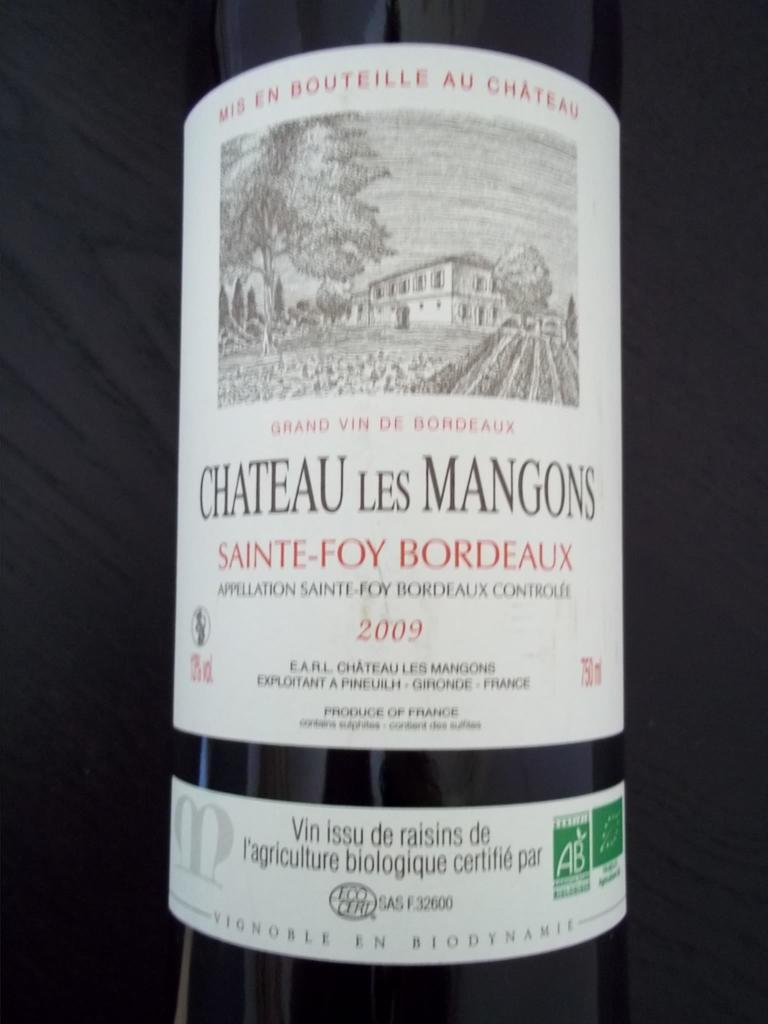<image>
Summarize the visual content of the image. A bottle of wine from Chateau les Mangons was bottled in 2009. 